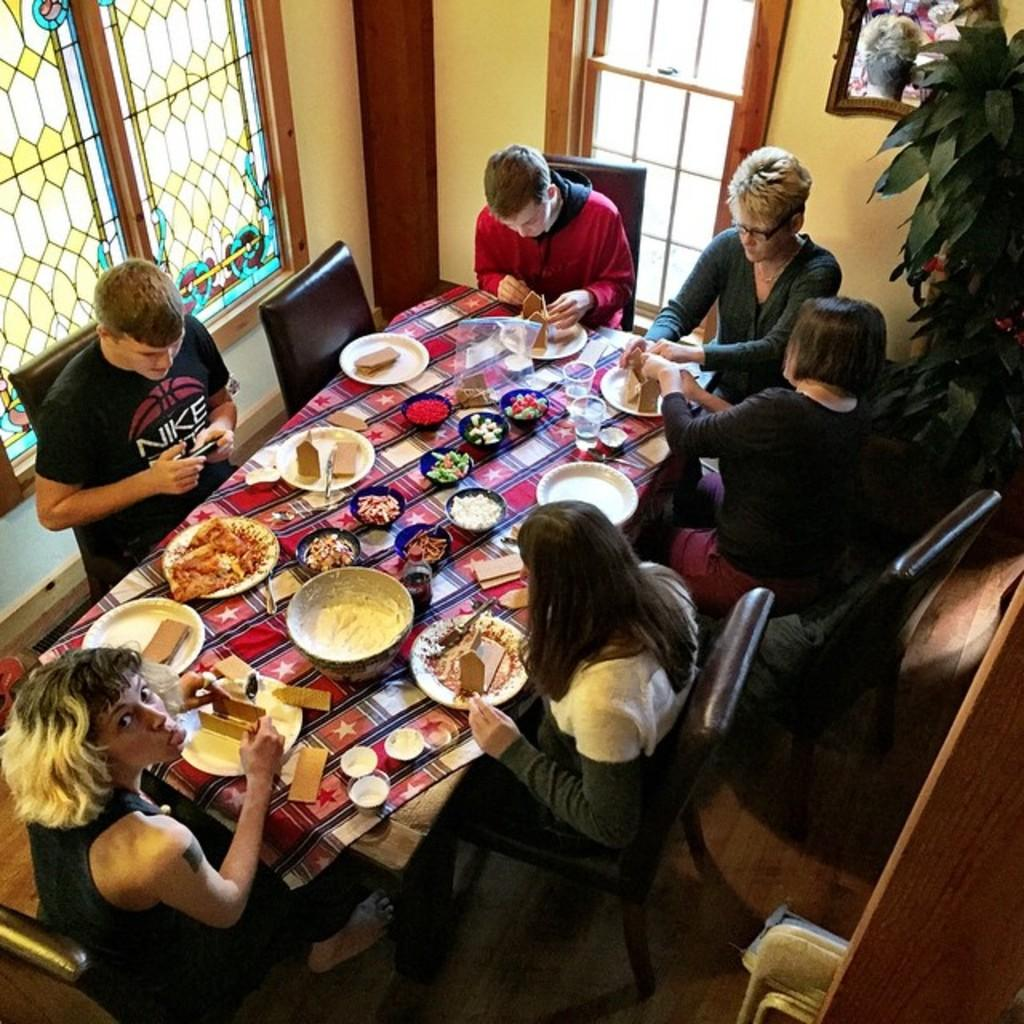What are the persons in the image doing? The persons in the image are sitting on chairs. What is in front of the persons? There is a table in front of the persons. What can be found on the table? There is a bowl, cups, a plate, and food on the table. What is beside the persons? There is a plant beside the persons. What can be seen through the windows in the image? The windows in the image allow us to see the outside environment. How many oranges are on the table in the image? There is no mention of oranges in the image; the table contains a bowl, cups, a plate, and food. What type of mine is visible in the image? There is no mine present in the image; it features persons sitting at a table with various items. 